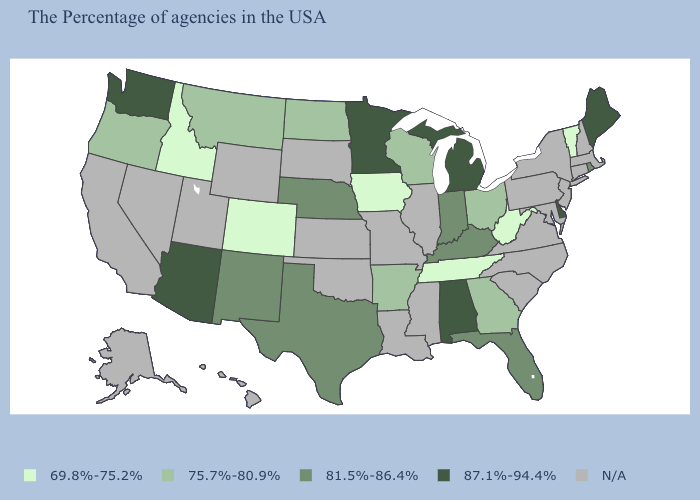What is the value of Utah?
Keep it brief. N/A. Does Washington have the lowest value in the USA?
Keep it brief. No. How many symbols are there in the legend?
Quick response, please. 5. Name the states that have a value in the range 69.8%-75.2%?
Concise answer only. Vermont, West Virginia, Tennessee, Iowa, Colorado, Idaho. Among the states that border Kansas , which have the highest value?
Write a very short answer. Nebraska. What is the highest value in the USA?
Quick response, please. 87.1%-94.4%. Does Maine have the lowest value in the USA?
Answer briefly. No. Among the states that border Connecticut , which have the lowest value?
Short answer required. Rhode Island. Name the states that have a value in the range 69.8%-75.2%?
Write a very short answer. Vermont, West Virginia, Tennessee, Iowa, Colorado, Idaho. What is the highest value in the MidWest ?
Concise answer only. 87.1%-94.4%. Name the states that have a value in the range N/A?
Concise answer only. Massachusetts, New Hampshire, Connecticut, New York, New Jersey, Maryland, Pennsylvania, Virginia, North Carolina, South Carolina, Illinois, Mississippi, Louisiana, Missouri, Kansas, Oklahoma, South Dakota, Wyoming, Utah, Nevada, California, Alaska, Hawaii. Does Idaho have the lowest value in the West?
Be succinct. Yes. What is the value of Nevada?
Write a very short answer. N/A. 